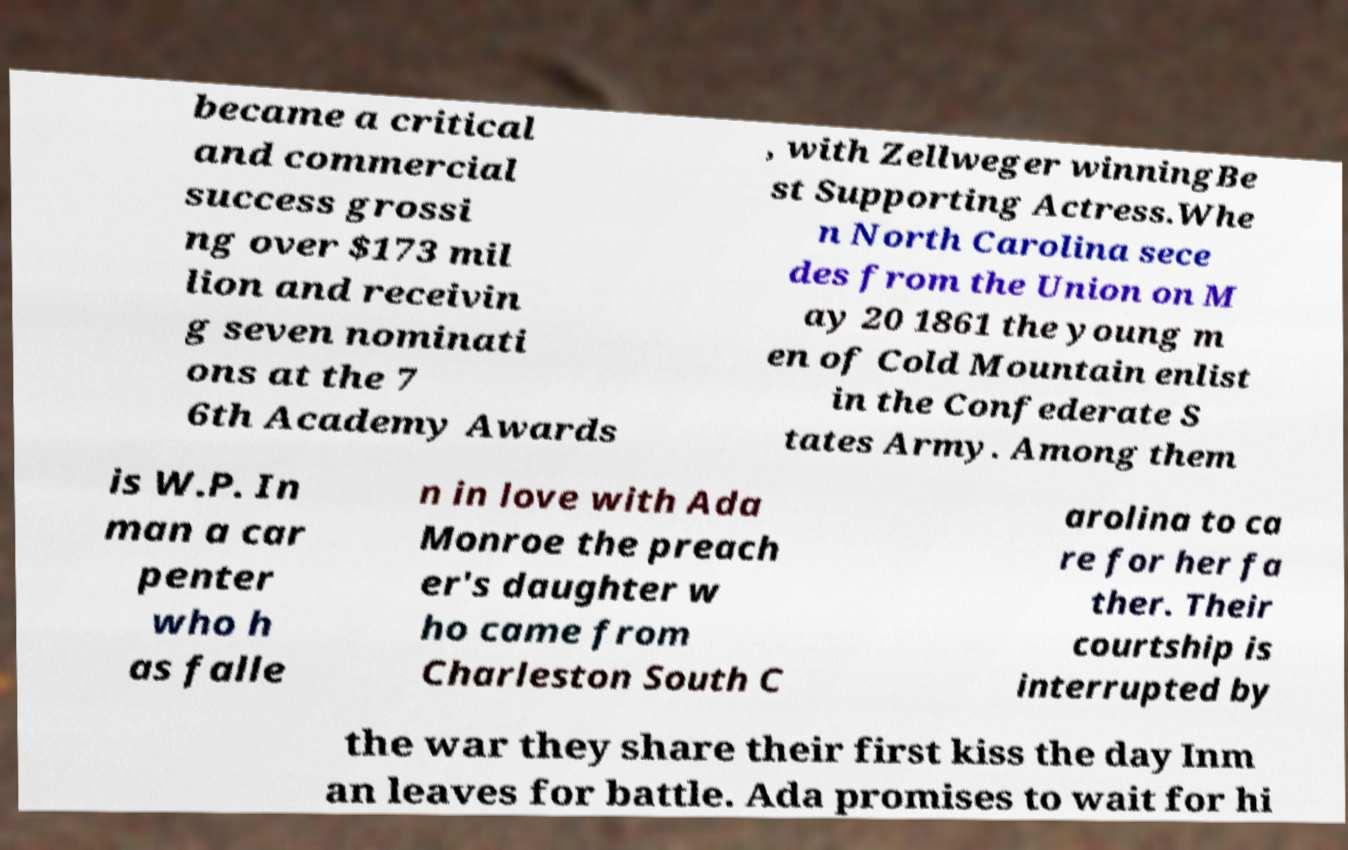For documentation purposes, I need the text within this image transcribed. Could you provide that? became a critical and commercial success grossi ng over $173 mil lion and receivin g seven nominati ons at the 7 6th Academy Awards , with Zellweger winningBe st Supporting Actress.Whe n North Carolina sece des from the Union on M ay 20 1861 the young m en of Cold Mountain enlist in the Confederate S tates Army. Among them is W.P. In man a car penter who h as falle n in love with Ada Monroe the preach er's daughter w ho came from Charleston South C arolina to ca re for her fa ther. Their courtship is interrupted by the war they share their first kiss the day Inm an leaves for battle. Ada promises to wait for hi 